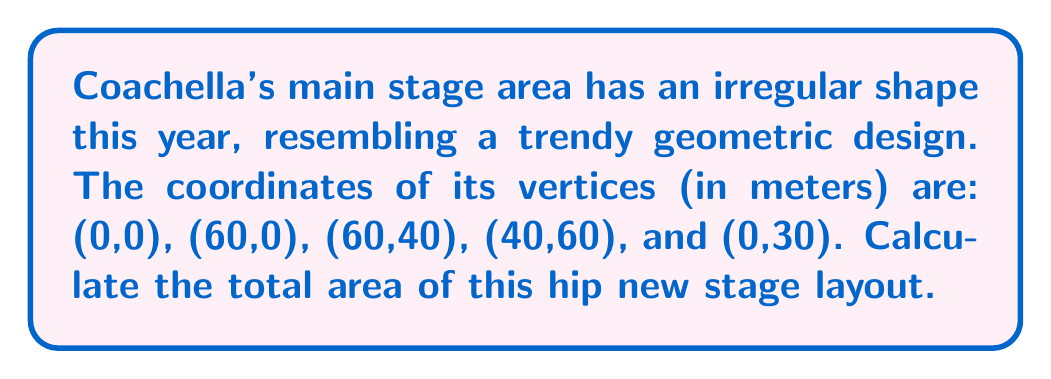Can you answer this question? Let's approach this step-by-step using the shoelace formula (also known as the surveyor's formula) to calculate the area of the irregular polygon:

1) First, let's list our coordinates in order:
   (0,0), (60,0), (60,40), (40,60), (0,30)

2) The shoelace formula is:

   $$A = \frac{1}{2}|\sum_{i=1}^{n-1} (x_iy_{i+1} - x_{i+1}y_i) + (x_ny_1 - x_1y_n)|$$

3) Let's calculate each term:
   $(0 \cdot 0) - (60 \cdot 0) = 0$
   $(60 \cdot 40) - (60 \cdot 0) = 2400$
   $(60 \cdot 60) - (40 \cdot 40) = 2000$
   $(40 \cdot 30) - (0 \cdot 60) = 1200$
   $(0 \cdot 0) - (0 \cdot 30) = 0$

4) Sum these values:
   $0 + 2400 + 2000 + 1200 + 0 = 5600$

5) Multiply by $\frac{1}{2}$:
   $\frac{1}{2} \cdot 5600 = 2800$

Therefore, the area of the Coachella main stage is 2800 square meters.

[asy]
unitsize(2mm);
draw((0,0)--(60,0)--(60,40)--(40,60)--(0,30)--cycle);
label("(0,0)", (0,0), SW);
label("(60,0)", (60,0), SE);
label("(60,40)", (60,40), E);
label("(40,60)", (40,60), N);
label("(0,30)", (0,30), W);
[/asy]
Answer: 2800 m² 